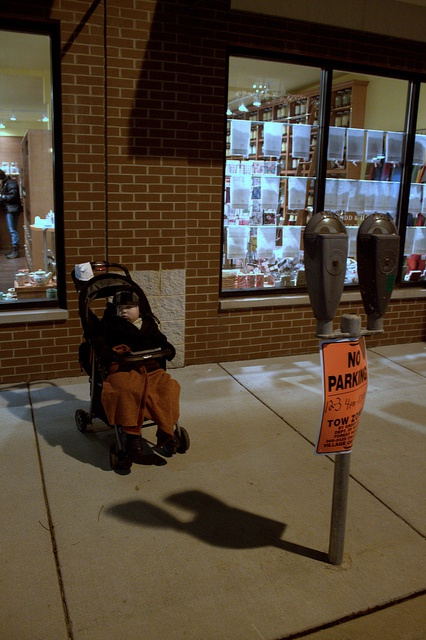Describe the objects in this image and their specific colors. I can see people in black, maroon, and gray tones, parking meter in black and gray tones, parking meter in black and gray tones, and people in black, gray, and blue tones in this image. 